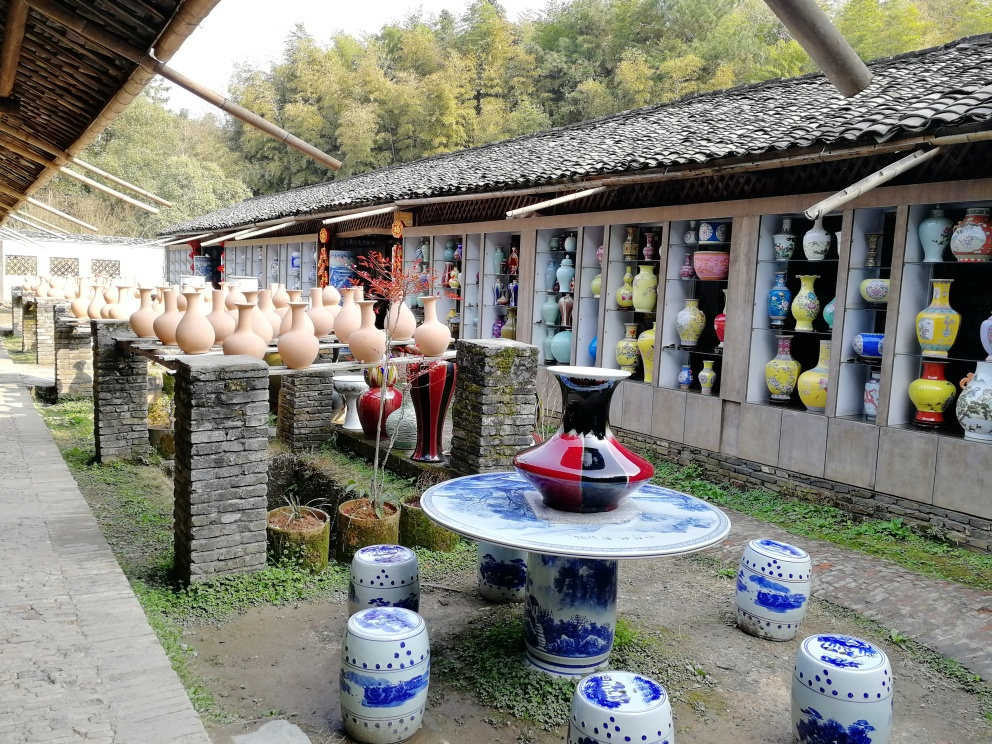Can you describe the setting of this image? This image showcases a tranquil outdoor setting, possibly part of a pottery market or gallery. A collection of traditional ceramic pots is displayed on stone pillars, while more ornate and colorful vases are visible inside the structure, suggesting a showcase of local craftsmanship. The presence of porcelain garden stools and tables with a distinctive blue and white pattern adds to the cultural ambiance, hinting at a setting that celebrates ceramic arts, likely in a region with a rich pottery heritage. 